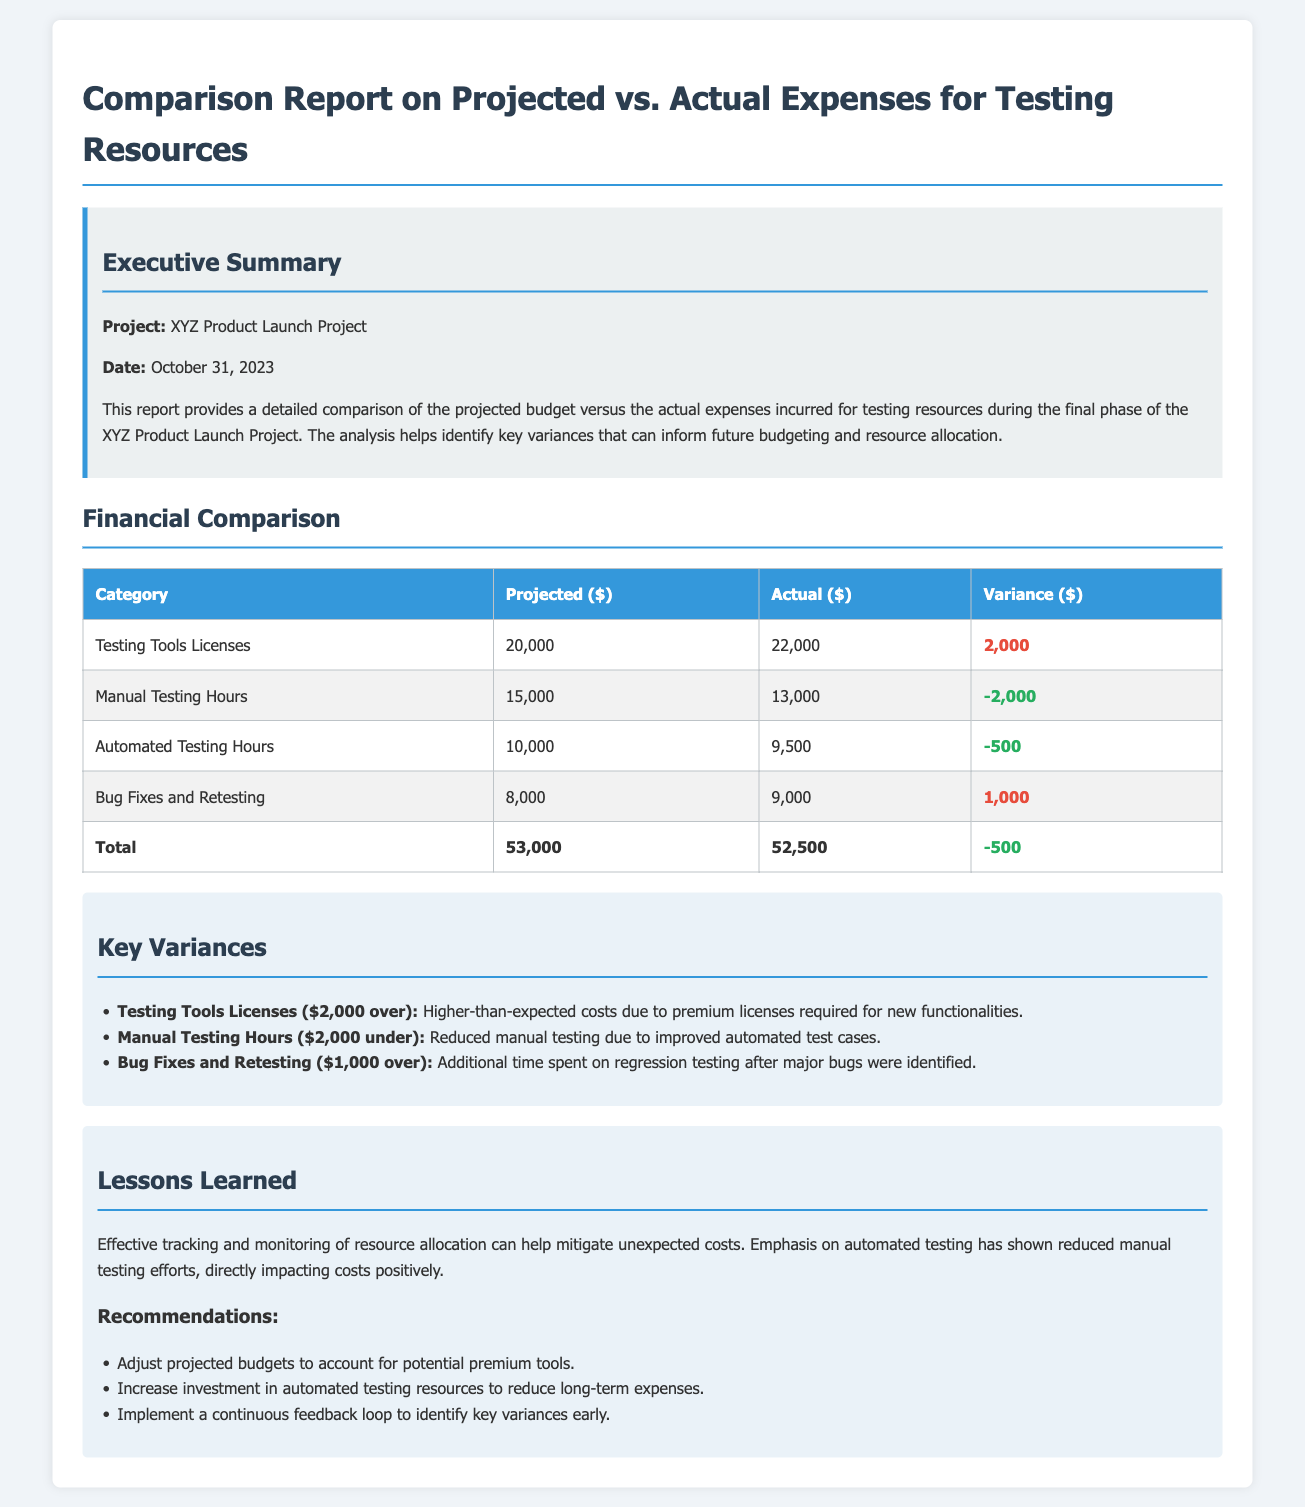What is the project name? The project name is mentioned in the executive summary of the report as the XYZ Product Launch Project.
Answer: XYZ Product Launch Project What is the date of the report? The date is specified in the executive summary section and indicates when the report was created.
Answer: October 31, 2023 What was the projected expense for Testing Tools Licenses? The projected expense for Testing Tools Licenses can be found in the financial comparison table under the Projected column.
Answer: 20,000 What was the actual expense for Manual Testing Hours? The actual expense is located in the financial comparison table under the Actual column for Manual Testing Hours.
Answer: 13,000 What is the total actual expense? The total actual expense can be obtained by looking at the Total row in the financial comparison table.
Answer: 52,500 How much over budget was the Testing Tools Licenses? The variance for Testing Tools Licenses shows how much over the budget it was.
Answer: 2,000 What lesson was learned regarding manual testing? The lesson learned discusses the impact of automated testing on manual testing hours.
Answer: Reduced manual testing due to improved automated test cases What is one recommendation made in the report? The recommendations section suggests actions to address variances and improve budgeting for future phases.
Answer: Adjust projected budgets to account for potential premium tools 